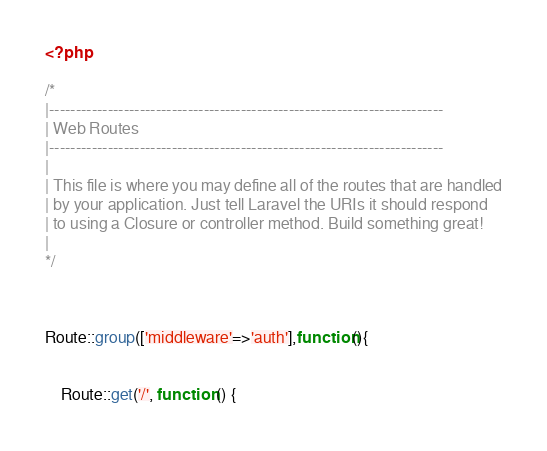Convert code to text. <code><loc_0><loc_0><loc_500><loc_500><_PHP_><?php

/*
|--------------------------------------------------------------------------
| Web Routes
|--------------------------------------------------------------------------
|
| This file is where you may define all of the routes that are handled
| by your application. Just tell Laravel the URIs it should respond
| to using a Closure or controller method. Build something great!
|
*/



Route::group(['middleware'=>'auth'],function(){


    Route::get('/', function () {</code> 